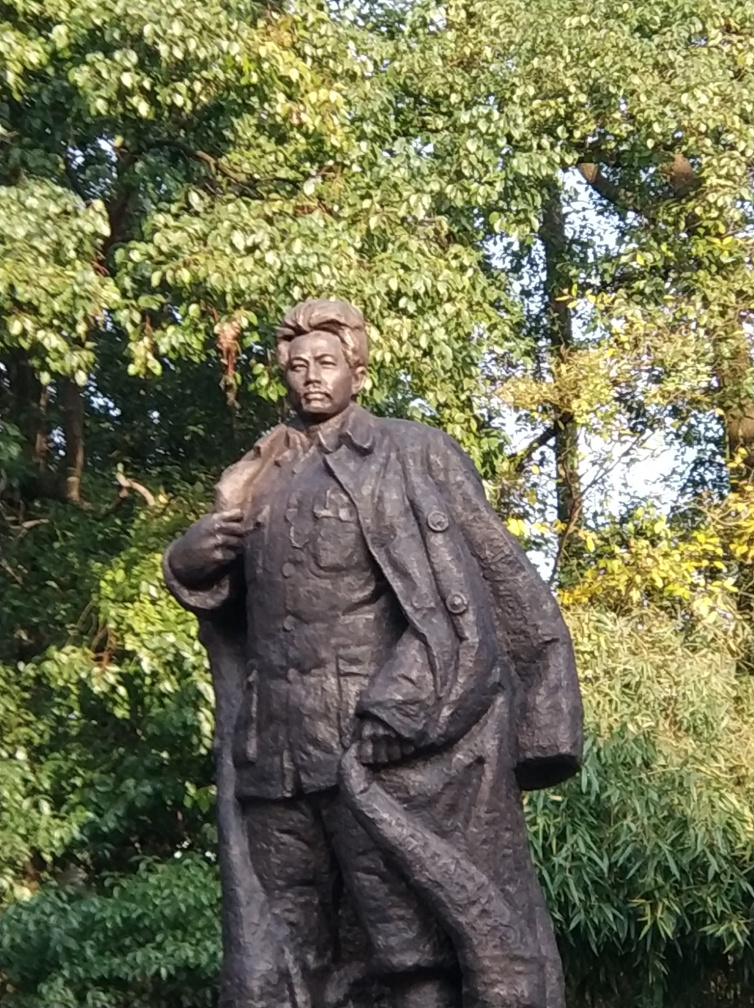Is there a slight motion blur present in the image? Yes, upon close inspection of the image, it appears there is a slight motion blur. This is often caused by subtle movement of the camera or the subject during the exposure, resulting in a softness of detail which is particularly noticeable in the textures of the statue and foliage. 